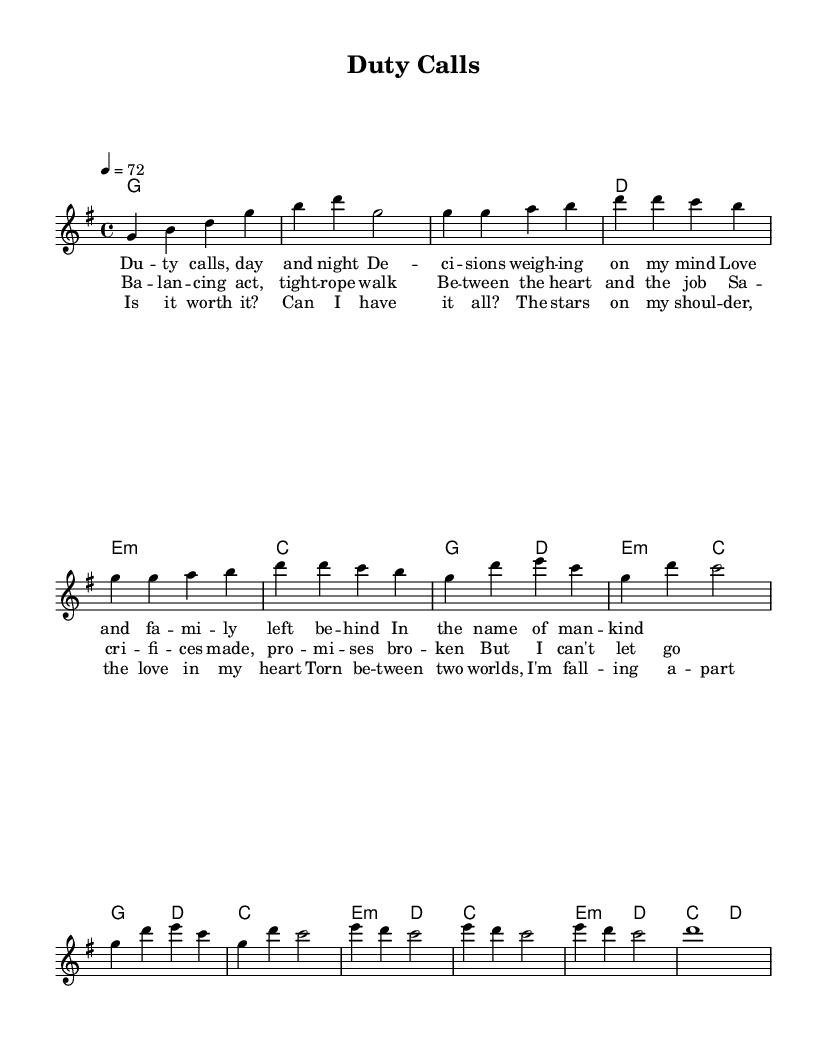What is the key signature of this music? The key signature indicated in the sheet music is G major, which has one sharp (F#). This can be identified in the global section where the command "\key g \major" specifies G major.
Answer: G major What is the time signature of this music? The time signature in the music is 4/4, as indicated in the global section with the command "\time 4/4". This means there are four beats in each measure, and the quarter note gets one beat.
Answer: 4/4 What is the tempo marking of this piece? The tempo marking specified in the sheet music is 72 beats per minute, as noted by the command "\tempo 4 = 72". This indicates the speed at which the piece should be performed.
Answer: 72 How many measures are in the chorus section? Counting the measures in the chorus section shows that there are four measures. This can be verified by analyzing the melody and harmonies specifically labeled as "Chorus" in the sheet music.
Answer: four What are the key themes addressed in the lyrics? The lyrics discuss themes of balancing personal life and career challenges, reflecting on sacrifices and emotional conflicts between job responsibilities and family love. This can be gathered from the content of the lyrics provided in the verse and chorus sections.
Answer: balance What musical form does this piece use? The piece follows a verse-chorus-bridge structure, a common form in pop music. This can be recognized by the distinct sections of the melody and lyrics organized into verses, a chorus, and a bridge, showing a clear arrangement.
Answer: verse-chorus-bridge What is the emotional tone of the bridge lyrics? The emotional tone of the bridge lyrics is one of conflict and introspection, expressing feelings of being torn between two worlds and questioning the worth of sacrifices made for a career. This can be deduced from the content of the bridge lyrics that reflect a struggle.
Answer: conflict 